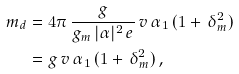<formula> <loc_0><loc_0><loc_500><loc_500>m _ { d } & = 4 \pi \, \frac { g } { g _ { m } \, | \alpha | ^ { 2 } \, e } \, v \, \alpha _ { 1 } \, ( 1 + \, \delta ^ { 2 } _ { m } ) \\ & = g \, v \, \alpha _ { 1 } \, ( 1 + \, \delta ^ { 2 } _ { m } ) \, ,</formula> 